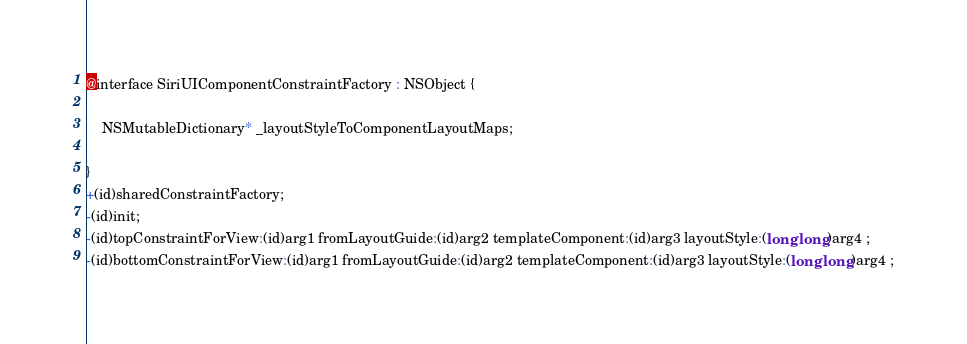Convert code to text. <code><loc_0><loc_0><loc_500><loc_500><_C_>@interface SiriUIComponentConstraintFactory : NSObject {

	NSMutableDictionary* _layoutStyleToComponentLayoutMaps;

}
+(id)sharedConstraintFactory;
-(id)init;
-(id)topConstraintForView:(id)arg1 fromLayoutGuide:(id)arg2 templateComponent:(id)arg3 layoutStyle:(long long)arg4 ;
-(id)bottomConstraintForView:(id)arg1 fromLayoutGuide:(id)arg2 templateComponent:(id)arg3 layoutStyle:(long long)arg4 ;</code> 